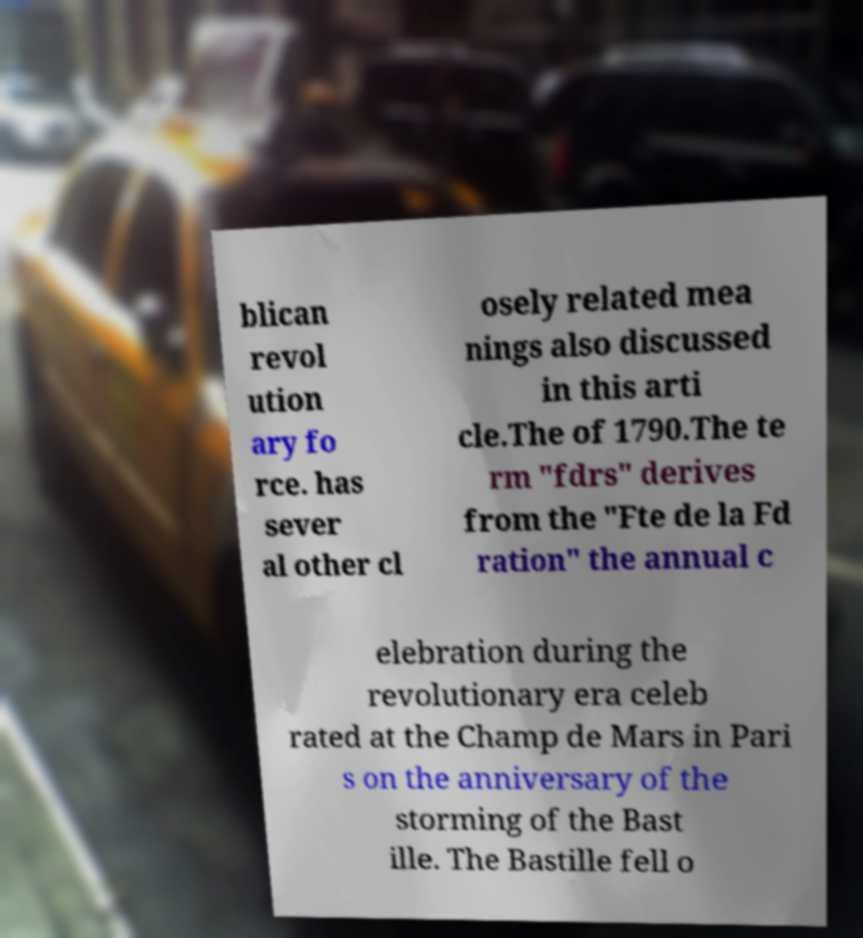Can you read and provide the text displayed in the image?This photo seems to have some interesting text. Can you extract and type it out for me? blican revol ution ary fo rce. has sever al other cl osely related mea nings also discussed in this arti cle.The of 1790.The te rm "fdrs" derives from the "Fte de la Fd ration" the annual c elebration during the revolutionary era celeb rated at the Champ de Mars in Pari s on the anniversary of the storming of the Bast ille. The Bastille fell o 